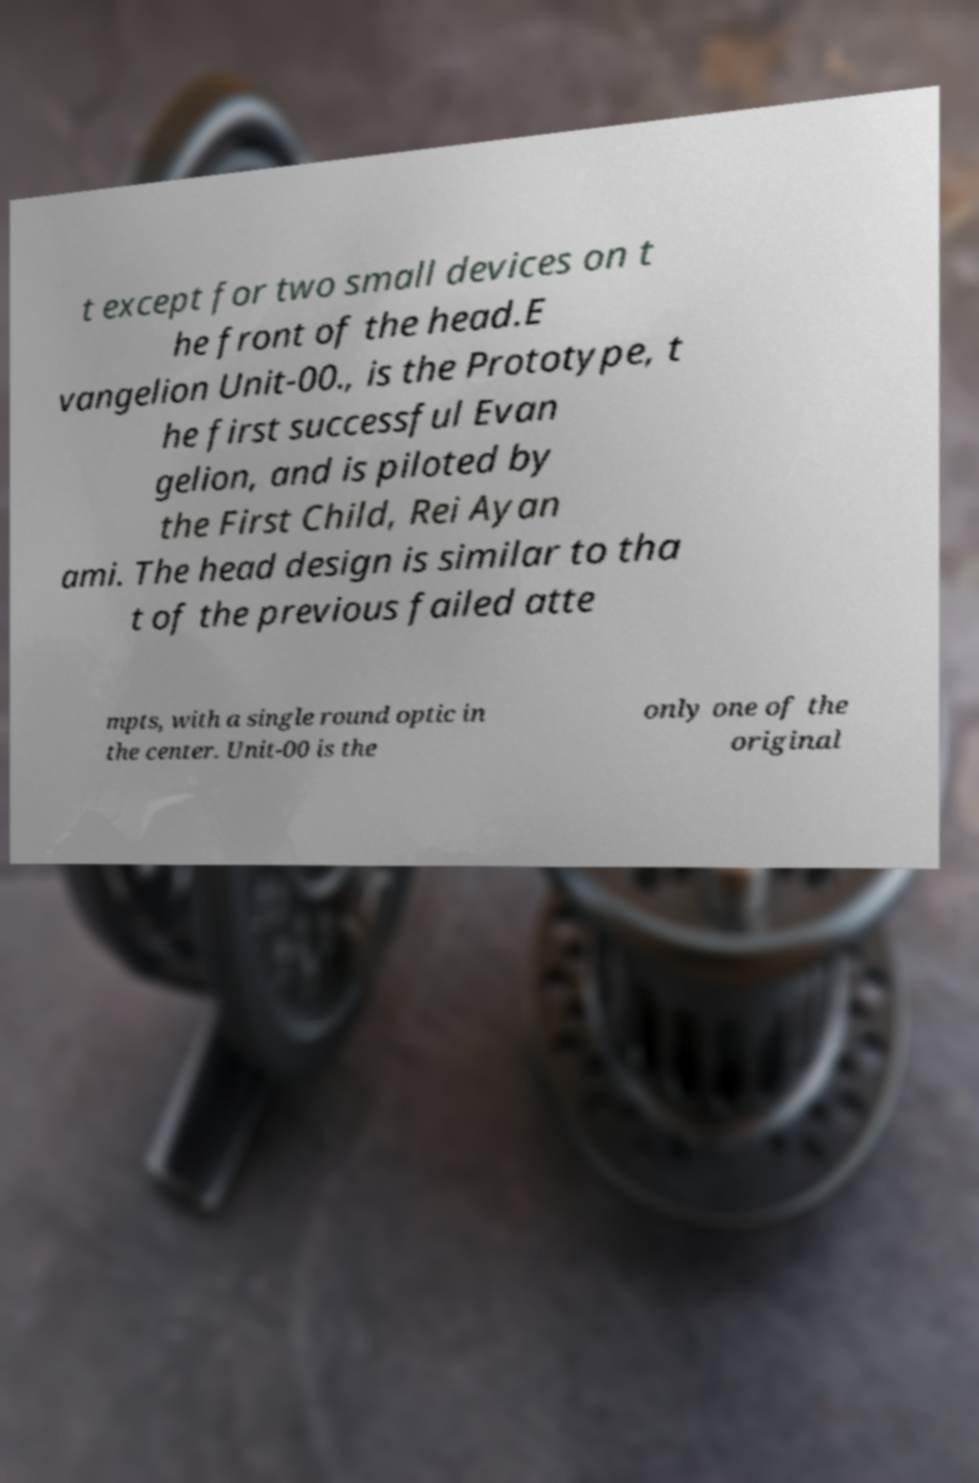Can you accurately transcribe the text from the provided image for me? t except for two small devices on t he front of the head.E vangelion Unit-00., is the Prototype, t he first successful Evan gelion, and is piloted by the First Child, Rei Ayan ami. The head design is similar to tha t of the previous failed atte mpts, with a single round optic in the center. Unit-00 is the only one of the original 